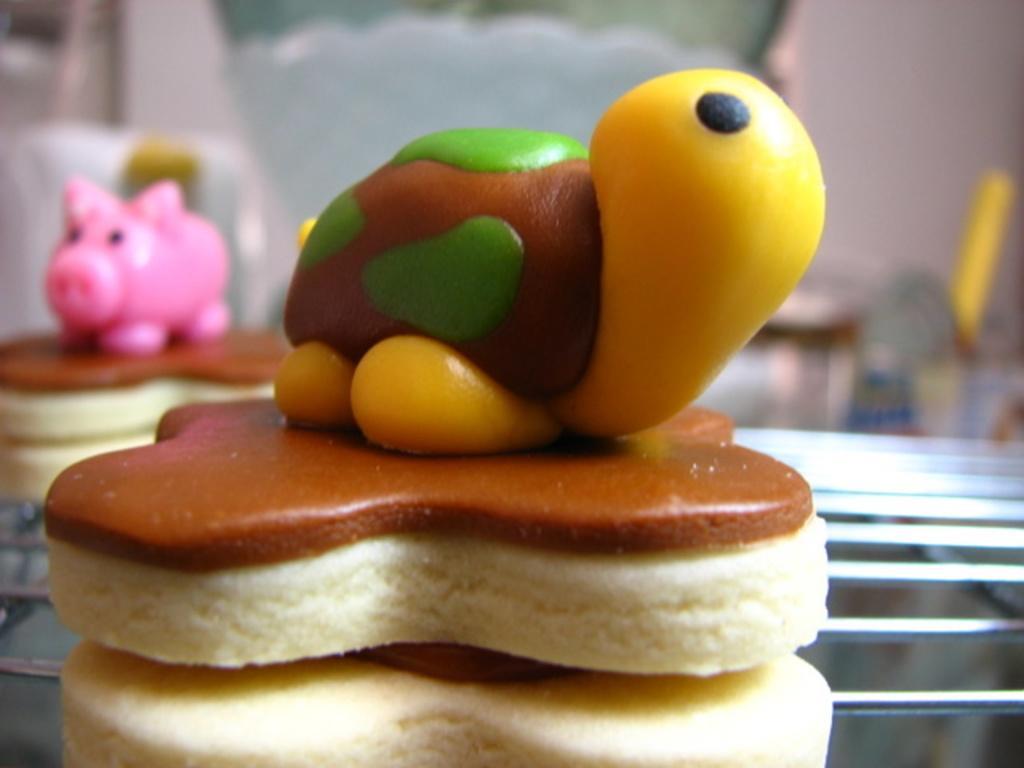Could you give a brief overview of what you see in this image? In this picture we can see some food on a grill. Background is blurry. 